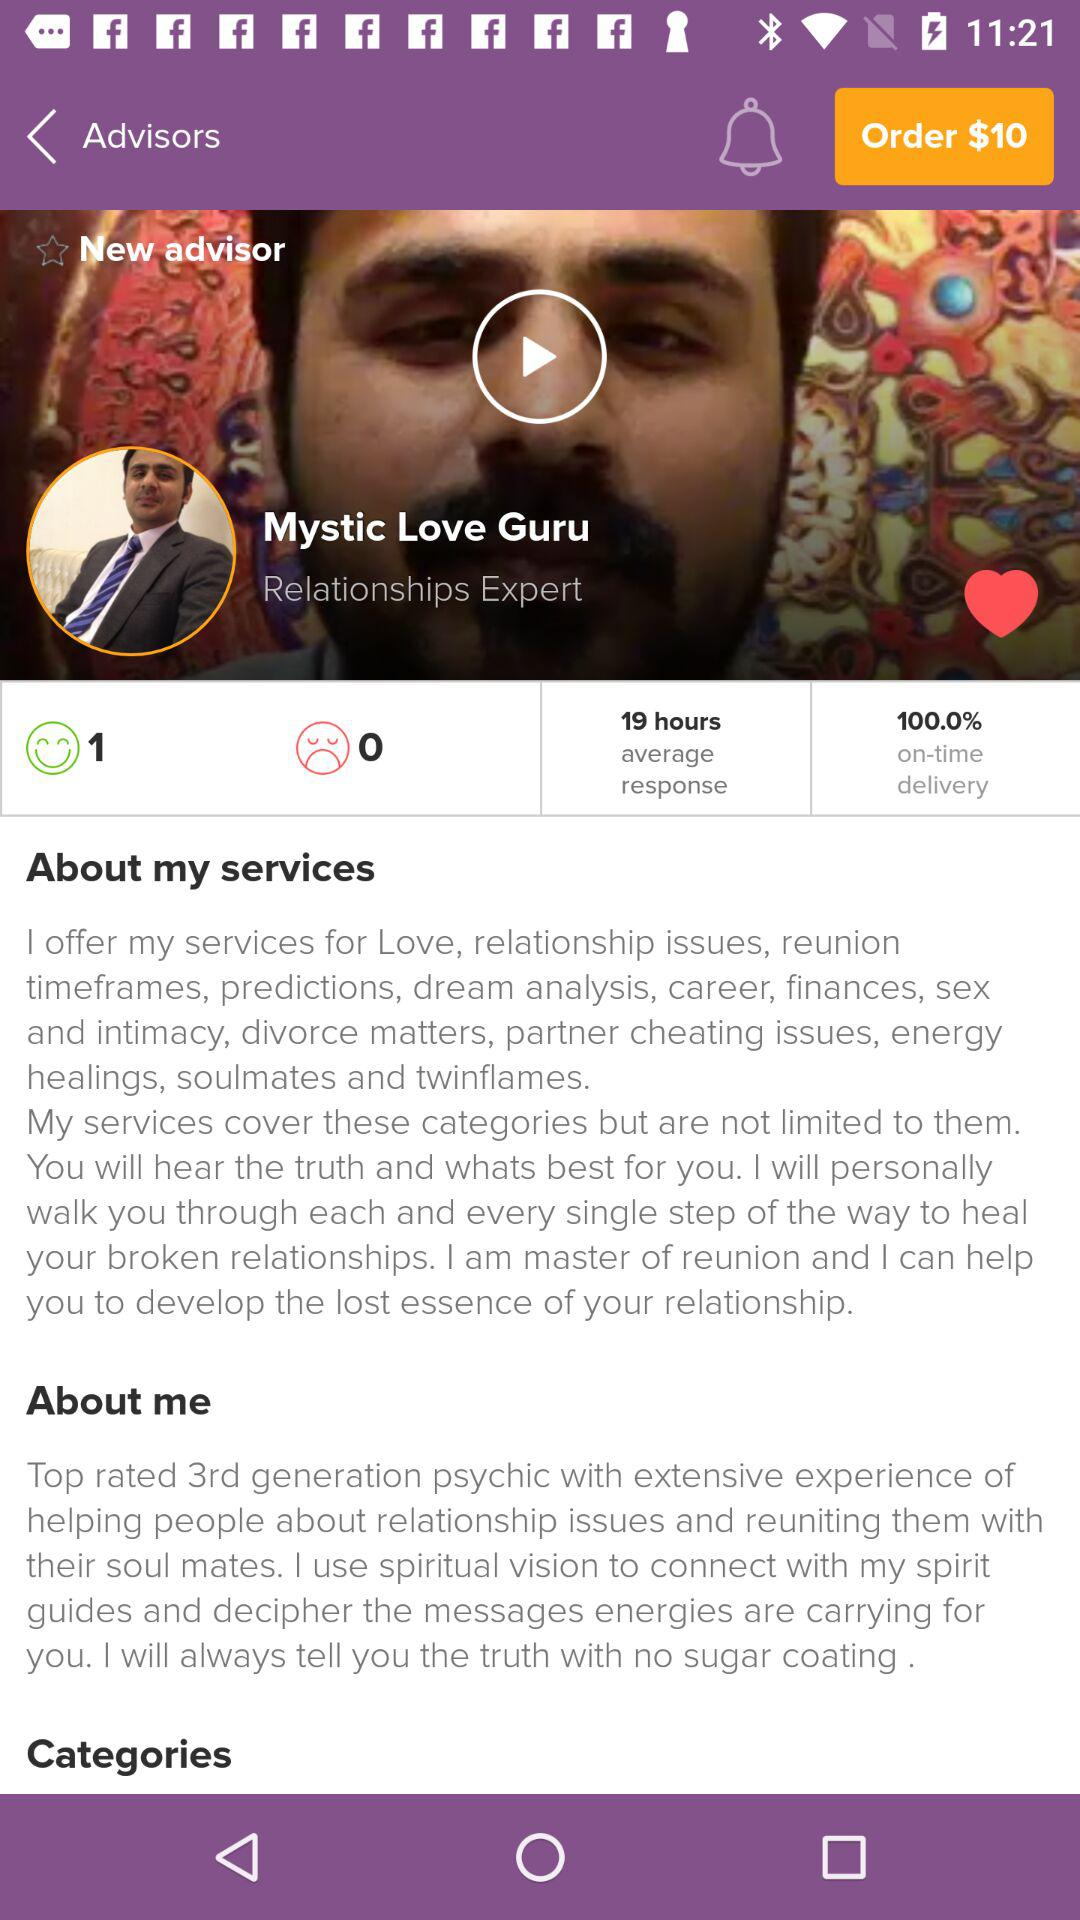How many more happy faces does the advisor have than sad faces?
Answer the question using a single word or phrase. 1 